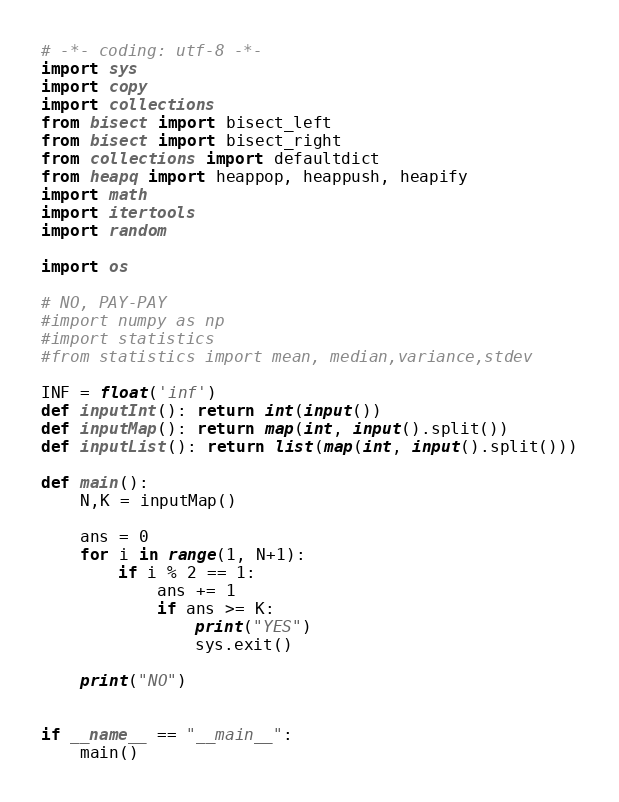<code> <loc_0><loc_0><loc_500><loc_500><_Python_># -*- coding: utf-8 -*-
import sys
import copy
import collections
from bisect import bisect_left
from bisect import bisect_right
from collections import defaultdict
from heapq import heappop, heappush, heapify
import math
import itertools
import random

import os
 
# NO, PAY-PAY
#import numpy as np
#import statistics
#from statistics import mean, median,variance,stdev
 
INF = float('inf')
def inputInt(): return int(input())
def inputMap(): return map(int, input().split())
def inputList(): return list(map(int, input().split()))
 
def main():
    N,K = inputMap()
    
    ans = 0
    for i in range(1, N+1):
        if i % 2 == 1:
            ans += 1
            if ans >= K:
                print("YES")
                sys.exit()
                
    print("NO")
    
    
if __name__ == "__main__":
	main()
</code> 